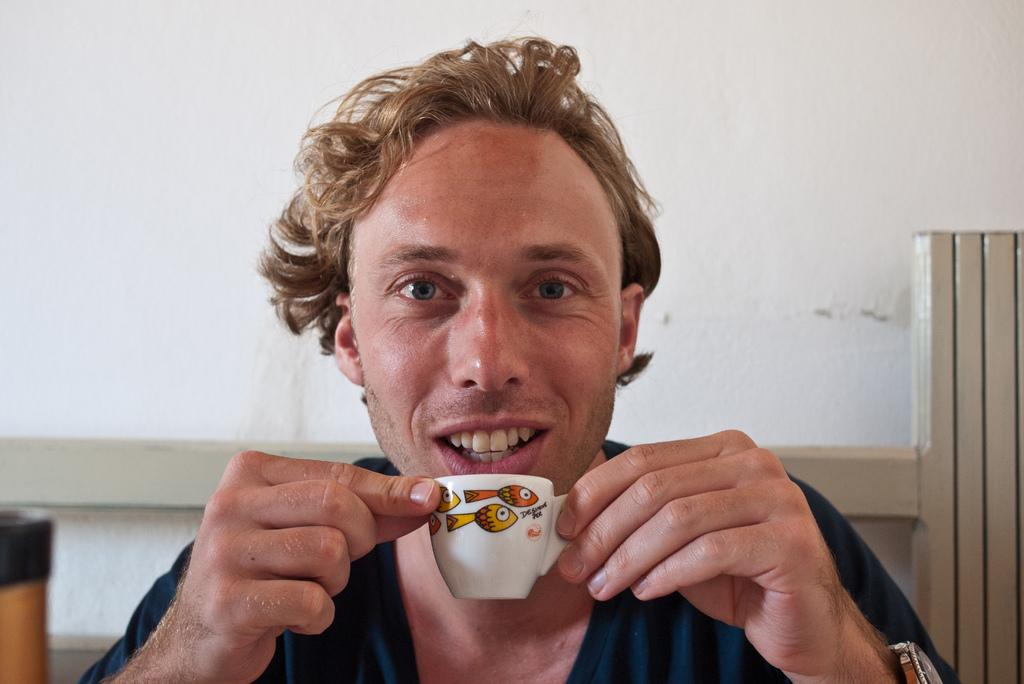What is the main subject of the image? There is a man sitting in the middle of the image. What is the man holding in the image? The man is holding a white cup. What can be seen in the background of the image? There is a white wall in the background of the image. What type of nerve can be seen in the image? There is no nerve visible in the image; it features a man sitting and holding a white cup in front of a white wall. 